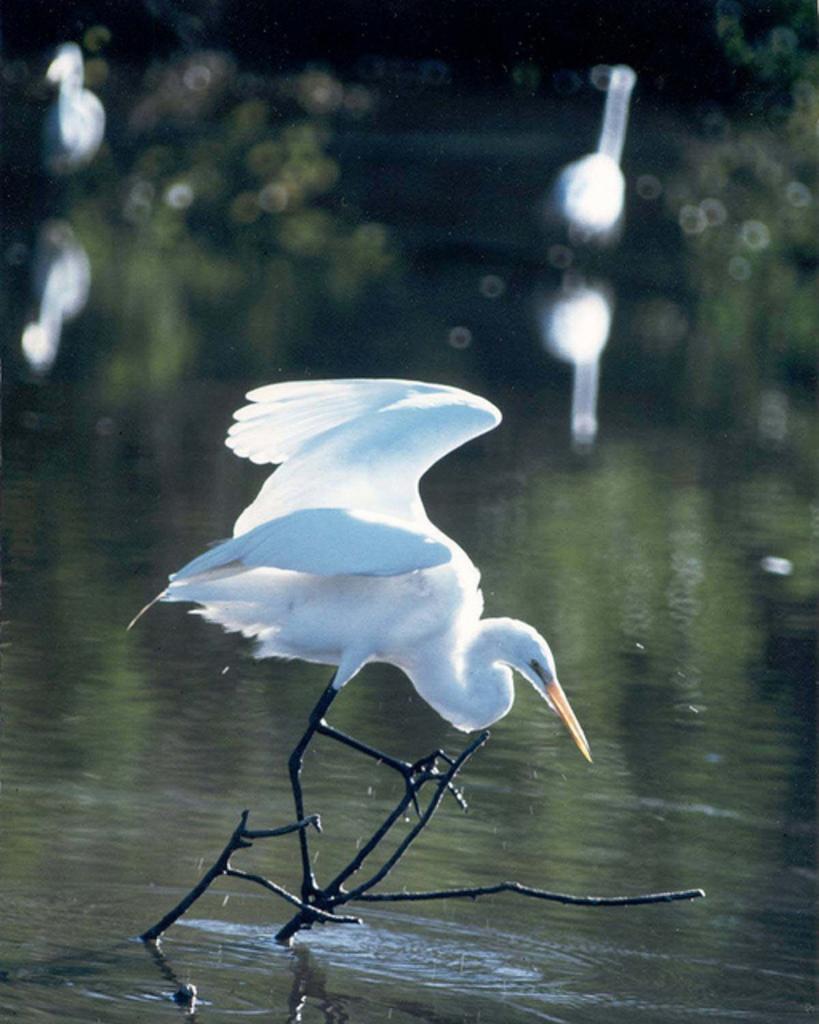Can you describe this image briefly? This picture is clicked outside the city. In the foreground we can see a white color bird seems to be flying in the air and we can see the stems of a tree and a water body. The background of the image is blurry and we can see there are some objects in the background. 